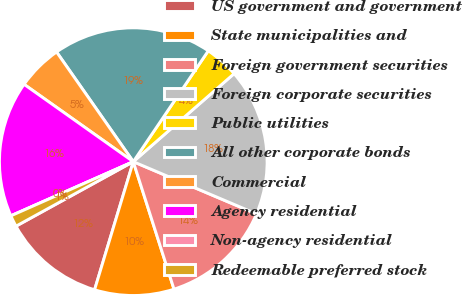<chart> <loc_0><loc_0><loc_500><loc_500><pie_chart><fcel>US government and government<fcel>State municipalities and<fcel>Foreign government securities<fcel>Foreign corporate securities<fcel>Public utilities<fcel>All other corporate bonds<fcel>Commercial<fcel>Agency residential<fcel>Non-agency residential<fcel>Redeemable preferred stock<nl><fcel>12.33%<fcel>9.59%<fcel>13.7%<fcel>17.81%<fcel>4.11%<fcel>19.18%<fcel>5.48%<fcel>16.44%<fcel>0.0%<fcel>1.37%<nl></chart> 